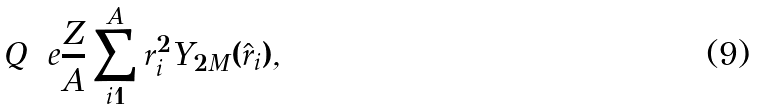<formula> <loc_0><loc_0><loc_500><loc_500>Q = e \frac { Z } { A } \sum _ { i = 1 } ^ { A } r _ { i } ^ { 2 } Y _ { 2 M } ( \hat { r } _ { i } ) ,</formula> 